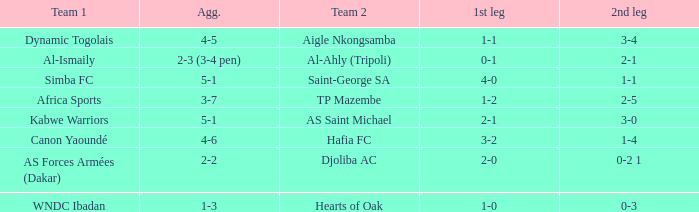When Kabwe Warriors (team 1) played, what was the result of the 1st leg? 2-1. Can you give me this table as a dict? {'header': ['Team 1', 'Agg.', 'Team 2', '1st leg', '2nd leg'], 'rows': [['Dynamic Togolais', '4-5', 'Aigle Nkongsamba', '1-1', '3-4'], ['Al-Ismaily', '2-3 (3-4 pen)', 'Al-Ahly (Tripoli)', '0-1', '2-1'], ['Simba FC', '5-1', 'Saint-George SA', '4-0', '1-1'], ['Africa Sports', '3-7', 'TP Mazembe', '1-2', '2-5'], ['Kabwe Warriors', '5-1', 'AS Saint Michael', '2-1', '3-0'], ['Canon Yaoundé', '4-6', 'Hafia FC', '3-2', '1-4'], ['AS Forces Armées (Dakar)', '2-2', 'Djoliba AC', '2-0', '0-2 1'], ['WNDC Ibadan', '1-3', 'Hearts of Oak', '1-0', '0-3']]} 